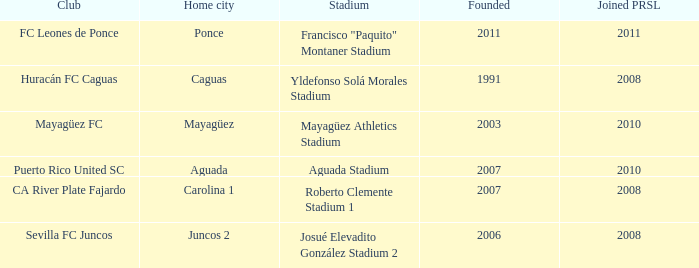When is the club founded that founed prsl in 2008 and the home city is carolina 1? 2007.0. 